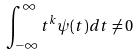<formula> <loc_0><loc_0><loc_500><loc_500>\int _ { - \infty } ^ { \infty } t ^ { k } \psi ( t ) d t \ne 0</formula> 